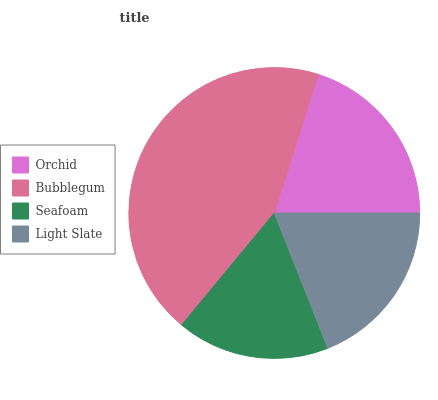Is Seafoam the minimum?
Answer yes or no. Yes. Is Bubblegum the maximum?
Answer yes or no. Yes. Is Bubblegum the minimum?
Answer yes or no. No. Is Seafoam the maximum?
Answer yes or no. No. Is Bubblegum greater than Seafoam?
Answer yes or no. Yes. Is Seafoam less than Bubblegum?
Answer yes or no. Yes. Is Seafoam greater than Bubblegum?
Answer yes or no. No. Is Bubblegum less than Seafoam?
Answer yes or no. No. Is Orchid the high median?
Answer yes or no. Yes. Is Light Slate the low median?
Answer yes or no. Yes. Is Light Slate the high median?
Answer yes or no. No. Is Orchid the low median?
Answer yes or no. No. 